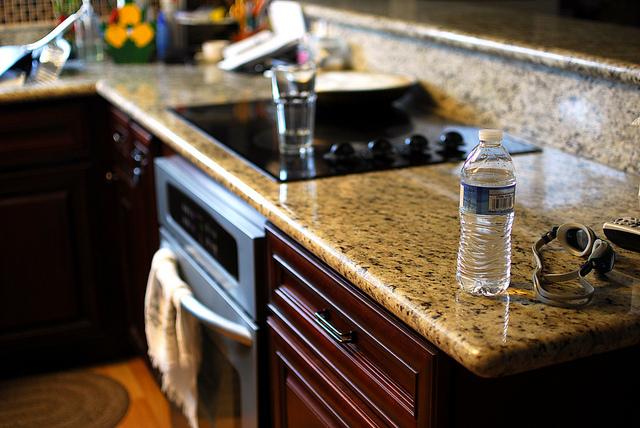Is this a kitchen?
Give a very brief answer. Yes. Is there any water in the bottle?
Short answer required. Yes. How many bottles?
Write a very short answer. 1. 